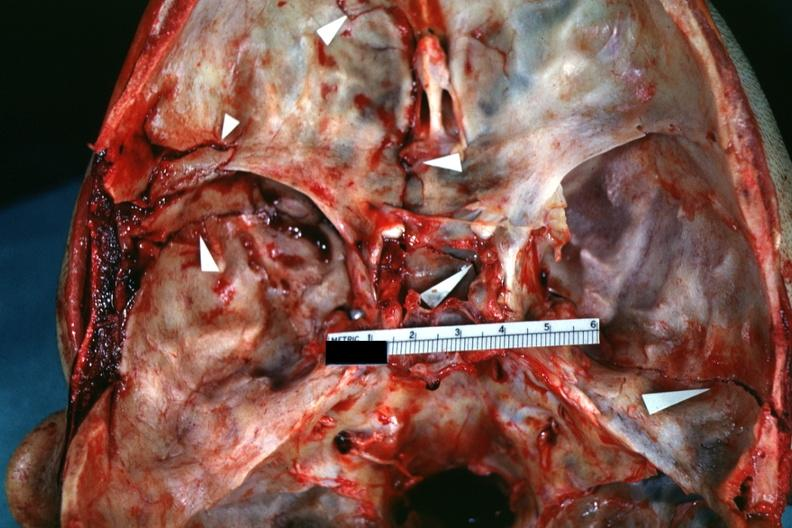does inflamed exocervix show close-up view of lesions slide which is brain from this case?
Answer the question using a single word or phrase. No 